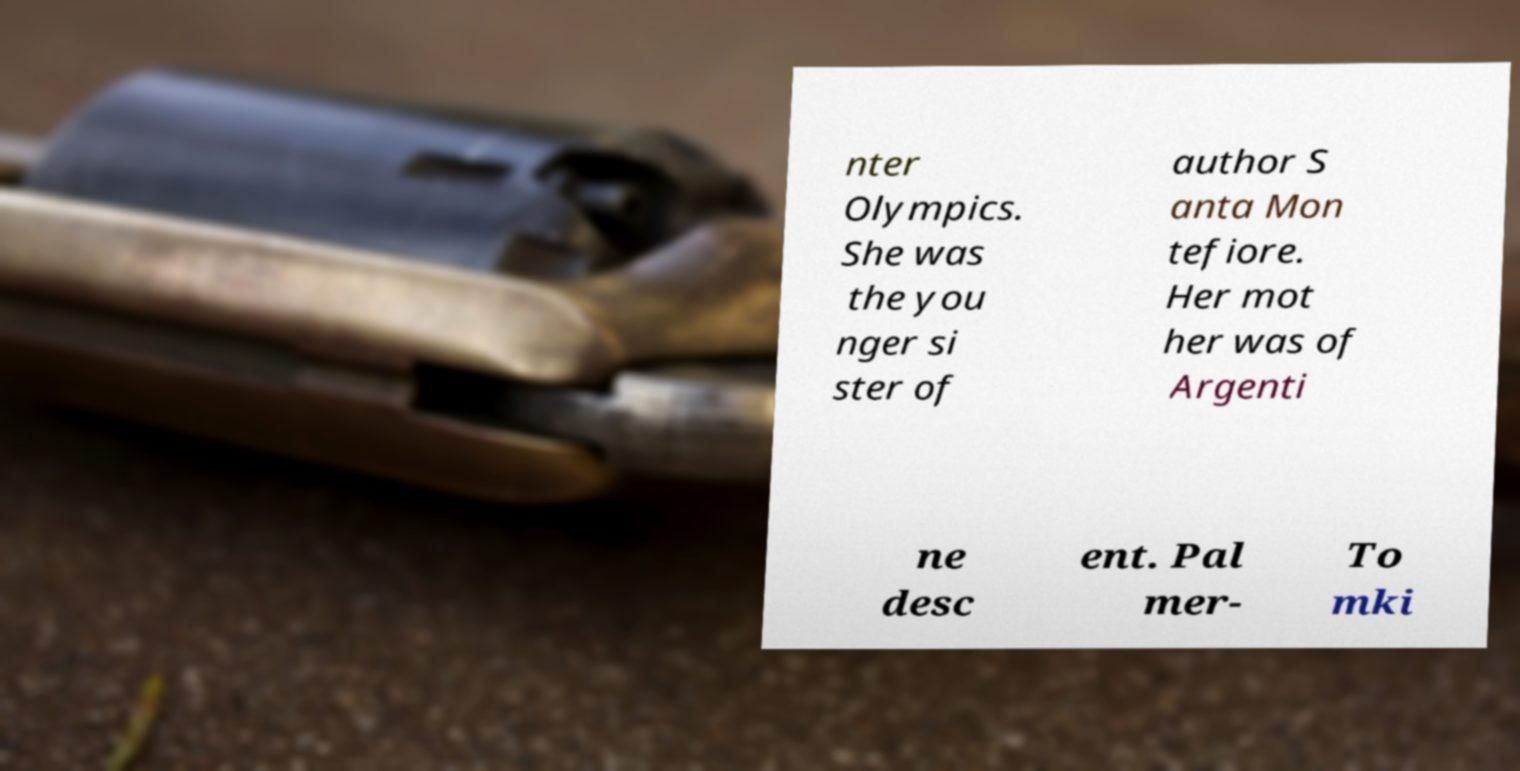I need the written content from this picture converted into text. Can you do that? nter Olympics. She was the you nger si ster of author S anta Mon tefiore. Her mot her was of Argenti ne desc ent. Pal mer- To mki 